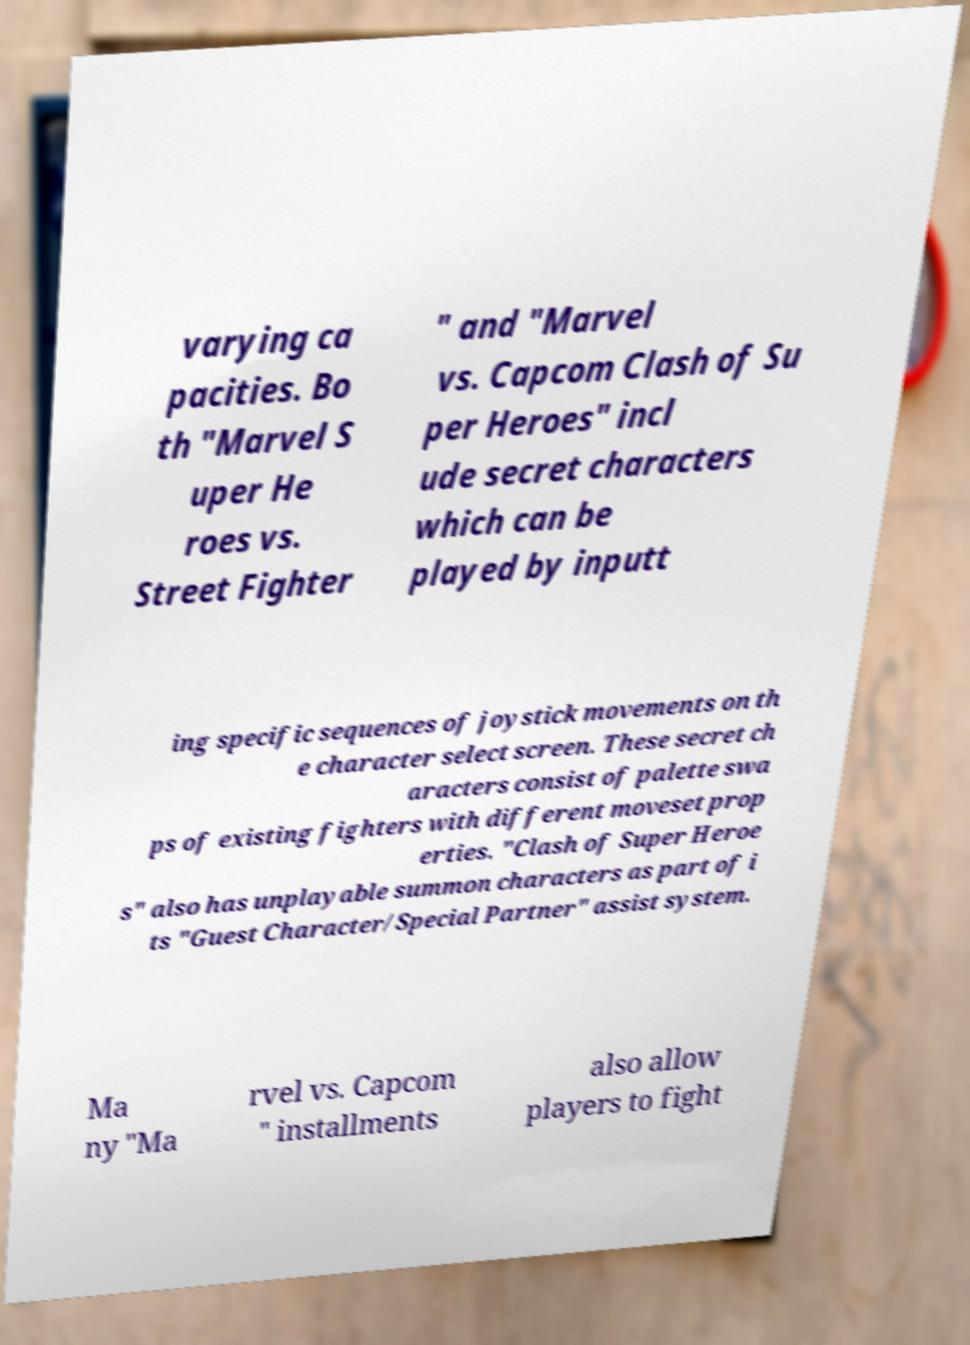I need the written content from this picture converted into text. Can you do that? varying ca pacities. Bo th "Marvel S uper He roes vs. Street Fighter " and "Marvel vs. Capcom Clash of Su per Heroes" incl ude secret characters which can be played by inputt ing specific sequences of joystick movements on th e character select screen. These secret ch aracters consist of palette swa ps of existing fighters with different moveset prop erties. "Clash of Super Heroe s" also has unplayable summon characters as part of i ts "Guest Character/Special Partner" assist system. Ma ny "Ma rvel vs. Capcom " installments also allow players to fight 